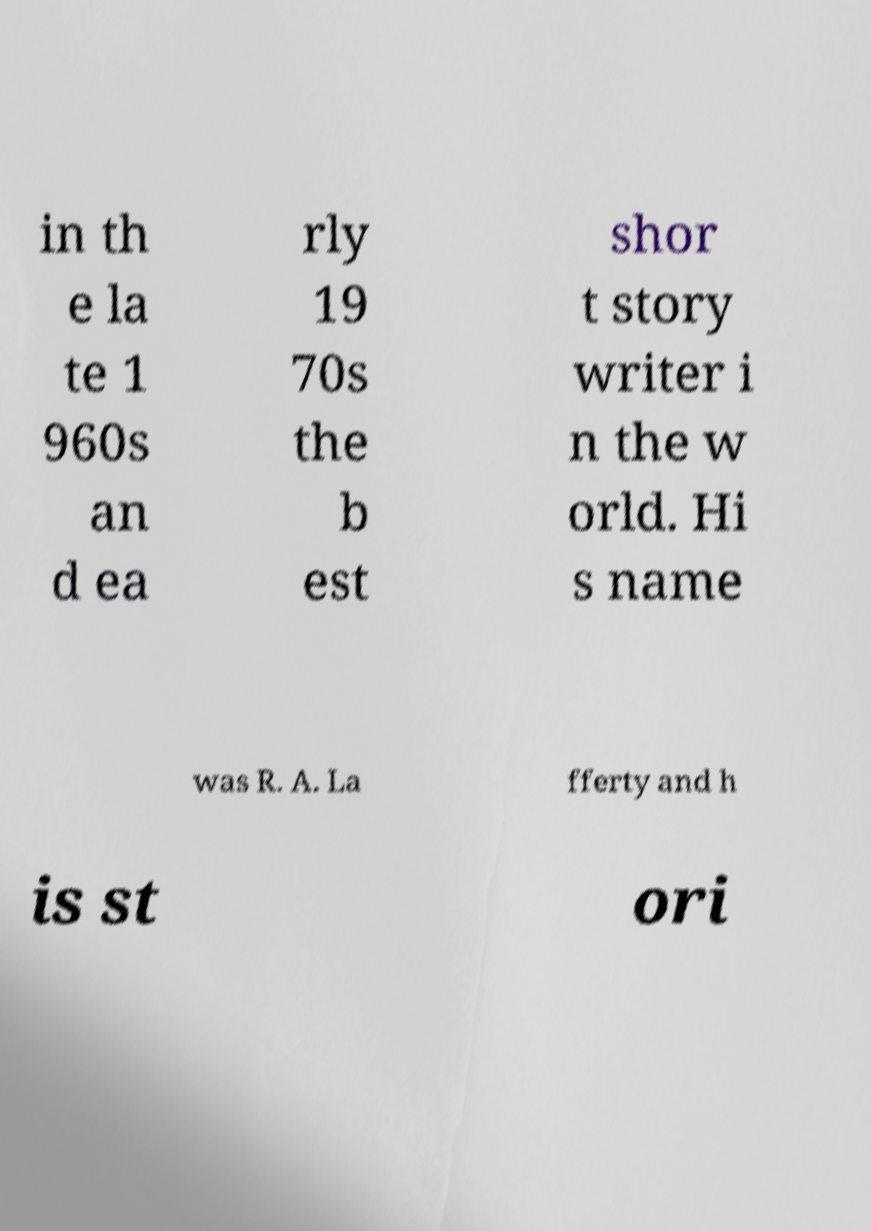Can you accurately transcribe the text from the provided image for me? in th e la te 1 960s an d ea rly 19 70s the b est shor t story writer i n the w orld. Hi s name was R. A. La fferty and h is st ori 